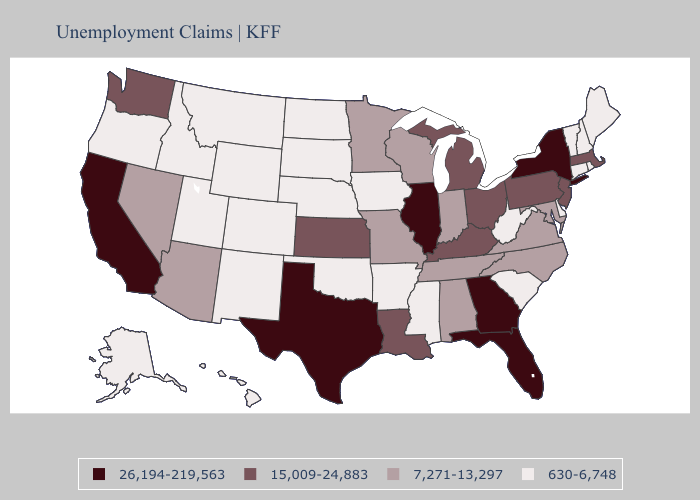Name the states that have a value in the range 15,009-24,883?
Write a very short answer. Kansas, Kentucky, Louisiana, Massachusetts, Michigan, New Jersey, Ohio, Pennsylvania, Washington. Which states hav the highest value in the Northeast?
Answer briefly. New York. Does New York have the same value as Missouri?
Write a very short answer. No. Name the states that have a value in the range 26,194-219,563?
Answer briefly. California, Florida, Georgia, Illinois, New York, Texas. Name the states that have a value in the range 15,009-24,883?
Give a very brief answer. Kansas, Kentucky, Louisiana, Massachusetts, Michigan, New Jersey, Ohio, Pennsylvania, Washington. Name the states that have a value in the range 26,194-219,563?
Keep it brief. California, Florida, Georgia, Illinois, New York, Texas. Does Alabama have the lowest value in the South?
Quick response, please. No. Name the states that have a value in the range 15,009-24,883?
Short answer required. Kansas, Kentucky, Louisiana, Massachusetts, Michigan, New Jersey, Ohio, Pennsylvania, Washington. Among the states that border Washington , which have the highest value?
Quick response, please. Idaho, Oregon. Name the states that have a value in the range 15,009-24,883?
Concise answer only. Kansas, Kentucky, Louisiana, Massachusetts, Michigan, New Jersey, Ohio, Pennsylvania, Washington. Among the states that border Connecticut , does New York have the highest value?
Keep it brief. Yes. Does Wyoming have a lower value than Maryland?
Give a very brief answer. Yes. What is the highest value in states that border Colorado?
Answer briefly. 15,009-24,883. Does Hawaii have the lowest value in the USA?
Short answer required. Yes. 